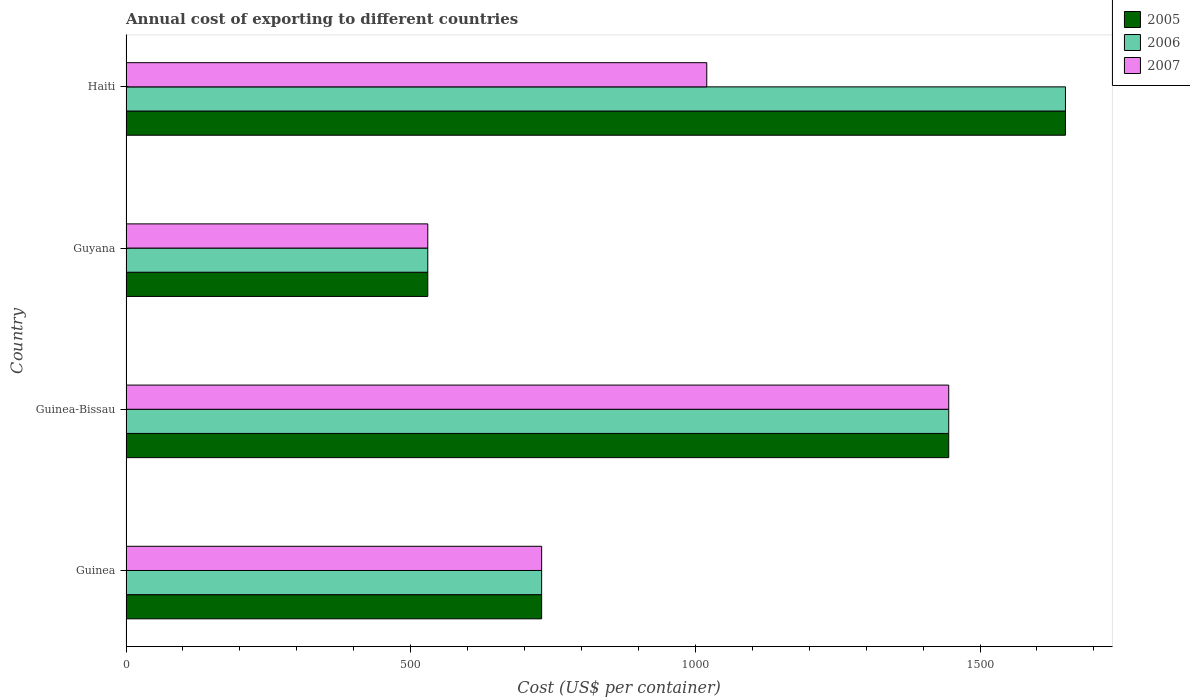How many different coloured bars are there?
Your answer should be very brief. 3. Are the number of bars on each tick of the Y-axis equal?
Your answer should be compact. Yes. How many bars are there on the 4th tick from the top?
Make the answer very short. 3. How many bars are there on the 4th tick from the bottom?
Your answer should be compact. 3. What is the label of the 1st group of bars from the top?
Make the answer very short. Haiti. In how many cases, is the number of bars for a given country not equal to the number of legend labels?
Offer a very short reply. 0. What is the total annual cost of exporting in 2006 in Guinea?
Your answer should be very brief. 730. Across all countries, what is the maximum total annual cost of exporting in 2005?
Provide a short and direct response. 1650. Across all countries, what is the minimum total annual cost of exporting in 2005?
Your answer should be compact. 530. In which country was the total annual cost of exporting in 2007 maximum?
Give a very brief answer. Guinea-Bissau. In which country was the total annual cost of exporting in 2006 minimum?
Your answer should be very brief. Guyana. What is the total total annual cost of exporting in 2006 in the graph?
Give a very brief answer. 4355. What is the difference between the total annual cost of exporting in 2005 in Guinea and that in Haiti?
Make the answer very short. -920. What is the difference between the total annual cost of exporting in 2005 in Guyana and the total annual cost of exporting in 2007 in Guinea-Bissau?
Your answer should be very brief. -915. What is the average total annual cost of exporting in 2005 per country?
Keep it short and to the point. 1088.75. In how many countries, is the total annual cost of exporting in 2005 greater than 200 US$?
Provide a succinct answer. 4. What is the ratio of the total annual cost of exporting in 2007 in Guyana to that in Haiti?
Your response must be concise. 0.52. Is the difference between the total annual cost of exporting in 2006 in Guinea and Guyana greater than the difference between the total annual cost of exporting in 2007 in Guinea and Guyana?
Your answer should be compact. No. What is the difference between the highest and the second highest total annual cost of exporting in 2006?
Keep it short and to the point. 205. What is the difference between the highest and the lowest total annual cost of exporting in 2005?
Your response must be concise. 1120. In how many countries, is the total annual cost of exporting in 2005 greater than the average total annual cost of exporting in 2005 taken over all countries?
Your response must be concise. 2. How many bars are there?
Provide a succinct answer. 12. Are all the bars in the graph horizontal?
Ensure brevity in your answer.  Yes. How many countries are there in the graph?
Offer a very short reply. 4. Does the graph contain grids?
Offer a very short reply. No. How many legend labels are there?
Your answer should be very brief. 3. How are the legend labels stacked?
Make the answer very short. Vertical. What is the title of the graph?
Your answer should be compact. Annual cost of exporting to different countries. What is the label or title of the X-axis?
Offer a terse response. Cost (US$ per container). What is the Cost (US$ per container) in 2005 in Guinea?
Your response must be concise. 730. What is the Cost (US$ per container) of 2006 in Guinea?
Provide a succinct answer. 730. What is the Cost (US$ per container) in 2007 in Guinea?
Your answer should be compact. 730. What is the Cost (US$ per container) in 2005 in Guinea-Bissau?
Your answer should be very brief. 1445. What is the Cost (US$ per container) of 2006 in Guinea-Bissau?
Your answer should be very brief. 1445. What is the Cost (US$ per container) of 2007 in Guinea-Bissau?
Keep it short and to the point. 1445. What is the Cost (US$ per container) in 2005 in Guyana?
Keep it short and to the point. 530. What is the Cost (US$ per container) of 2006 in Guyana?
Provide a succinct answer. 530. What is the Cost (US$ per container) of 2007 in Guyana?
Make the answer very short. 530. What is the Cost (US$ per container) in 2005 in Haiti?
Provide a succinct answer. 1650. What is the Cost (US$ per container) in 2006 in Haiti?
Provide a succinct answer. 1650. What is the Cost (US$ per container) of 2007 in Haiti?
Keep it short and to the point. 1020. Across all countries, what is the maximum Cost (US$ per container) of 2005?
Make the answer very short. 1650. Across all countries, what is the maximum Cost (US$ per container) of 2006?
Keep it short and to the point. 1650. Across all countries, what is the maximum Cost (US$ per container) in 2007?
Make the answer very short. 1445. Across all countries, what is the minimum Cost (US$ per container) in 2005?
Your answer should be very brief. 530. Across all countries, what is the minimum Cost (US$ per container) of 2006?
Provide a short and direct response. 530. Across all countries, what is the minimum Cost (US$ per container) of 2007?
Offer a terse response. 530. What is the total Cost (US$ per container) in 2005 in the graph?
Give a very brief answer. 4355. What is the total Cost (US$ per container) in 2006 in the graph?
Keep it short and to the point. 4355. What is the total Cost (US$ per container) in 2007 in the graph?
Give a very brief answer. 3725. What is the difference between the Cost (US$ per container) in 2005 in Guinea and that in Guinea-Bissau?
Your response must be concise. -715. What is the difference between the Cost (US$ per container) of 2006 in Guinea and that in Guinea-Bissau?
Make the answer very short. -715. What is the difference between the Cost (US$ per container) in 2007 in Guinea and that in Guinea-Bissau?
Keep it short and to the point. -715. What is the difference between the Cost (US$ per container) in 2005 in Guinea and that in Guyana?
Ensure brevity in your answer.  200. What is the difference between the Cost (US$ per container) in 2006 in Guinea and that in Guyana?
Your answer should be compact. 200. What is the difference between the Cost (US$ per container) of 2005 in Guinea and that in Haiti?
Keep it short and to the point. -920. What is the difference between the Cost (US$ per container) in 2006 in Guinea and that in Haiti?
Keep it short and to the point. -920. What is the difference between the Cost (US$ per container) of 2007 in Guinea and that in Haiti?
Make the answer very short. -290. What is the difference between the Cost (US$ per container) in 2005 in Guinea-Bissau and that in Guyana?
Provide a short and direct response. 915. What is the difference between the Cost (US$ per container) of 2006 in Guinea-Bissau and that in Guyana?
Your answer should be compact. 915. What is the difference between the Cost (US$ per container) in 2007 in Guinea-Bissau and that in Guyana?
Provide a succinct answer. 915. What is the difference between the Cost (US$ per container) in 2005 in Guinea-Bissau and that in Haiti?
Provide a short and direct response. -205. What is the difference between the Cost (US$ per container) in 2006 in Guinea-Bissau and that in Haiti?
Give a very brief answer. -205. What is the difference between the Cost (US$ per container) in 2007 in Guinea-Bissau and that in Haiti?
Provide a short and direct response. 425. What is the difference between the Cost (US$ per container) in 2005 in Guyana and that in Haiti?
Offer a very short reply. -1120. What is the difference between the Cost (US$ per container) of 2006 in Guyana and that in Haiti?
Give a very brief answer. -1120. What is the difference between the Cost (US$ per container) of 2007 in Guyana and that in Haiti?
Make the answer very short. -490. What is the difference between the Cost (US$ per container) in 2005 in Guinea and the Cost (US$ per container) in 2006 in Guinea-Bissau?
Keep it short and to the point. -715. What is the difference between the Cost (US$ per container) of 2005 in Guinea and the Cost (US$ per container) of 2007 in Guinea-Bissau?
Offer a terse response. -715. What is the difference between the Cost (US$ per container) in 2006 in Guinea and the Cost (US$ per container) in 2007 in Guinea-Bissau?
Your response must be concise. -715. What is the difference between the Cost (US$ per container) of 2005 in Guinea and the Cost (US$ per container) of 2007 in Guyana?
Keep it short and to the point. 200. What is the difference between the Cost (US$ per container) of 2005 in Guinea and the Cost (US$ per container) of 2006 in Haiti?
Provide a short and direct response. -920. What is the difference between the Cost (US$ per container) in 2005 in Guinea and the Cost (US$ per container) in 2007 in Haiti?
Offer a terse response. -290. What is the difference between the Cost (US$ per container) in 2006 in Guinea and the Cost (US$ per container) in 2007 in Haiti?
Your answer should be very brief. -290. What is the difference between the Cost (US$ per container) in 2005 in Guinea-Bissau and the Cost (US$ per container) in 2006 in Guyana?
Your response must be concise. 915. What is the difference between the Cost (US$ per container) in 2005 in Guinea-Bissau and the Cost (US$ per container) in 2007 in Guyana?
Your answer should be compact. 915. What is the difference between the Cost (US$ per container) in 2006 in Guinea-Bissau and the Cost (US$ per container) in 2007 in Guyana?
Make the answer very short. 915. What is the difference between the Cost (US$ per container) in 2005 in Guinea-Bissau and the Cost (US$ per container) in 2006 in Haiti?
Make the answer very short. -205. What is the difference between the Cost (US$ per container) of 2005 in Guinea-Bissau and the Cost (US$ per container) of 2007 in Haiti?
Keep it short and to the point. 425. What is the difference between the Cost (US$ per container) in 2006 in Guinea-Bissau and the Cost (US$ per container) in 2007 in Haiti?
Your response must be concise. 425. What is the difference between the Cost (US$ per container) in 2005 in Guyana and the Cost (US$ per container) in 2006 in Haiti?
Your answer should be compact. -1120. What is the difference between the Cost (US$ per container) of 2005 in Guyana and the Cost (US$ per container) of 2007 in Haiti?
Make the answer very short. -490. What is the difference between the Cost (US$ per container) of 2006 in Guyana and the Cost (US$ per container) of 2007 in Haiti?
Your answer should be very brief. -490. What is the average Cost (US$ per container) of 2005 per country?
Provide a short and direct response. 1088.75. What is the average Cost (US$ per container) of 2006 per country?
Offer a terse response. 1088.75. What is the average Cost (US$ per container) in 2007 per country?
Give a very brief answer. 931.25. What is the difference between the Cost (US$ per container) in 2005 and Cost (US$ per container) in 2006 in Guinea-Bissau?
Provide a succinct answer. 0. What is the difference between the Cost (US$ per container) of 2005 and Cost (US$ per container) of 2007 in Guinea-Bissau?
Your response must be concise. 0. What is the difference between the Cost (US$ per container) in 2005 and Cost (US$ per container) in 2007 in Haiti?
Ensure brevity in your answer.  630. What is the difference between the Cost (US$ per container) in 2006 and Cost (US$ per container) in 2007 in Haiti?
Provide a succinct answer. 630. What is the ratio of the Cost (US$ per container) in 2005 in Guinea to that in Guinea-Bissau?
Give a very brief answer. 0.51. What is the ratio of the Cost (US$ per container) of 2006 in Guinea to that in Guinea-Bissau?
Your answer should be compact. 0.51. What is the ratio of the Cost (US$ per container) of 2007 in Guinea to that in Guinea-Bissau?
Your answer should be compact. 0.51. What is the ratio of the Cost (US$ per container) of 2005 in Guinea to that in Guyana?
Ensure brevity in your answer.  1.38. What is the ratio of the Cost (US$ per container) of 2006 in Guinea to that in Guyana?
Provide a succinct answer. 1.38. What is the ratio of the Cost (US$ per container) in 2007 in Guinea to that in Guyana?
Your answer should be compact. 1.38. What is the ratio of the Cost (US$ per container) in 2005 in Guinea to that in Haiti?
Offer a very short reply. 0.44. What is the ratio of the Cost (US$ per container) in 2006 in Guinea to that in Haiti?
Offer a very short reply. 0.44. What is the ratio of the Cost (US$ per container) in 2007 in Guinea to that in Haiti?
Make the answer very short. 0.72. What is the ratio of the Cost (US$ per container) in 2005 in Guinea-Bissau to that in Guyana?
Ensure brevity in your answer.  2.73. What is the ratio of the Cost (US$ per container) in 2006 in Guinea-Bissau to that in Guyana?
Your response must be concise. 2.73. What is the ratio of the Cost (US$ per container) of 2007 in Guinea-Bissau to that in Guyana?
Provide a succinct answer. 2.73. What is the ratio of the Cost (US$ per container) in 2005 in Guinea-Bissau to that in Haiti?
Keep it short and to the point. 0.88. What is the ratio of the Cost (US$ per container) of 2006 in Guinea-Bissau to that in Haiti?
Offer a very short reply. 0.88. What is the ratio of the Cost (US$ per container) in 2007 in Guinea-Bissau to that in Haiti?
Keep it short and to the point. 1.42. What is the ratio of the Cost (US$ per container) of 2005 in Guyana to that in Haiti?
Your answer should be compact. 0.32. What is the ratio of the Cost (US$ per container) of 2006 in Guyana to that in Haiti?
Offer a terse response. 0.32. What is the ratio of the Cost (US$ per container) of 2007 in Guyana to that in Haiti?
Keep it short and to the point. 0.52. What is the difference between the highest and the second highest Cost (US$ per container) of 2005?
Offer a very short reply. 205. What is the difference between the highest and the second highest Cost (US$ per container) of 2006?
Provide a succinct answer. 205. What is the difference between the highest and the second highest Cost (US$ per container) of 2007?
Give a very brief answer. 425. What is the difference between the highest and the lowest Cost (US$ per container) of 2005?
Keep it short and to the point. 1120. What is the difference between the highest and the lowest Cost (US$ per container) in 2006?
Your answer should be very brief. 1120. What is the difference between the highest and the lowest Cost (US$ per container) in 2007?
Offer a terse response. 915. 